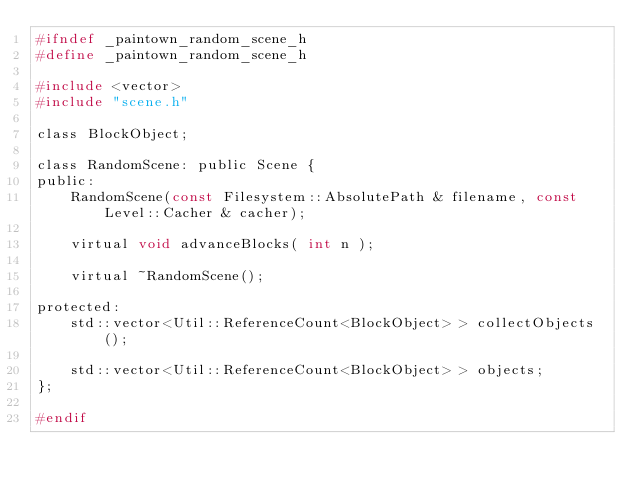<code> <loc_0><loc_0><loc_500><loc_500><_C_>#ifndef _paintown_random_scene_h
#define _paintown_random_scene_h

#include <vector>
#include "scene.h"

class BlockObject;

class RandomScene: public Scene {
public:
    RandomScene(const Filesystem::AbsolutePath & filename, const Level::Cacher & cacher);
	
    virtual void advanceBlocks( int n );

    virtual ~RandomScene();

protected:
    std::vector<Util::ReferenceCount<BlockObject> > collectObjects();

    std::vector<Util::ReferenceCount<BlockObject> > objects;
};

#endif
</code> 